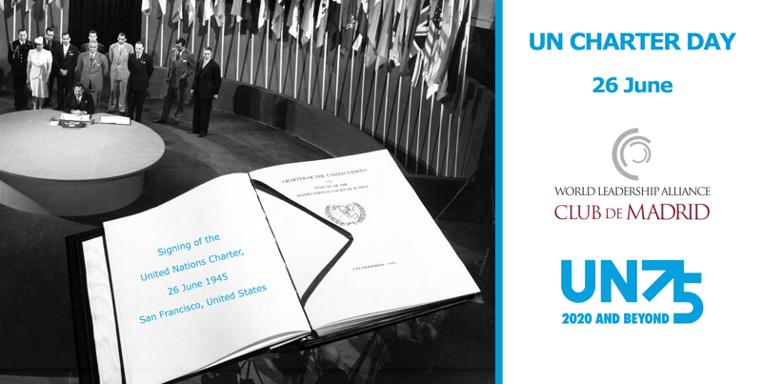Who are the individuals or the group symbolized by the emblem of the World Leadership Alliance Club de Madrid seen in the image? The emblem of the World Leadership Alliance Club de Madrid in the image represents a unique organization that comprises former heads of state and government. The Alliance fosters dialogue and collaboration to address global challenges and is dedicated to promoting democracy and humanitarian values. What is the significance of the name 'UN75' seen in the image? 'UN75' refers to the 75th anniversary of the United Nations, which was celebrated in 2020. The inclusion of 'UN75' in the image is emblematic of the ongoing commitment to the principles of the UN Charter and the endeavors to achieve a more peaceful and prosperous future as envisioned when the Charter was signed in 1945. 